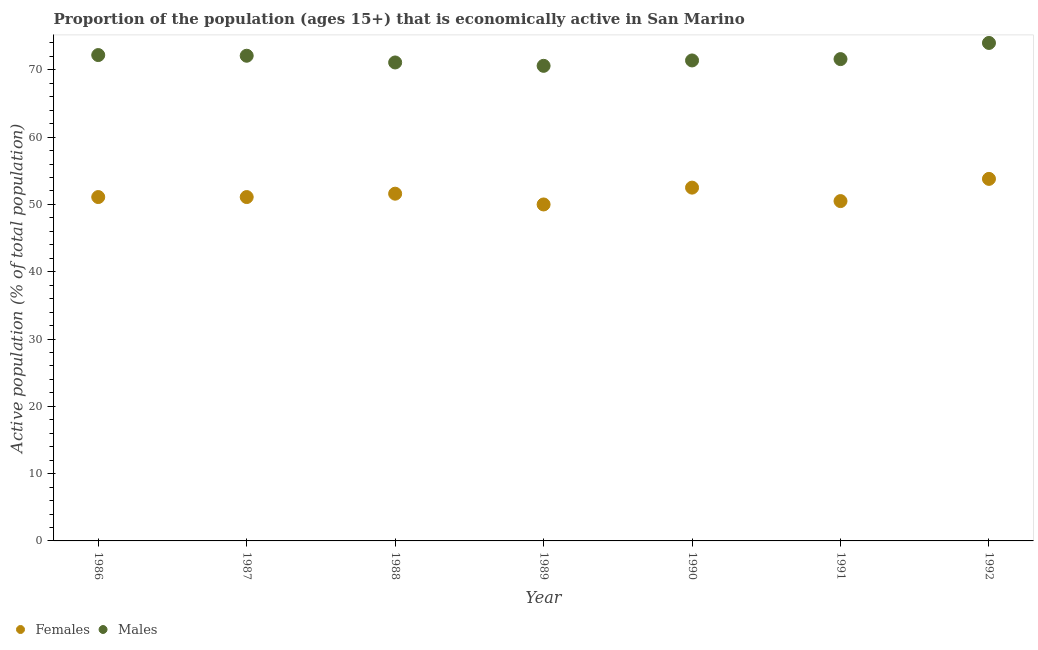How many different coloured dotlines are there?
Your answer should be very brief. 2. Is the number of dotlines equal to the number of legend labels?
Provide a succinct answer. Yes. What is the percentage of economically active female population in 1987?
Make the answer very short. 51.1. Across all years, what is the maximum percentage of economically active female population?
Ensure brevity in your answer.  53.8. In which year was the percentage of economically active female population minimum?
Make the answer very short. 1989. What is the total percentage of economically active female population in the graph?
Provide a short and direct response. 360.6. What is the difference between the percentage of economically active male population in 1987 and the percentage of economically active female population in 1991?
Keep it short and to the point. 21.6. What is the average percentage of economically active female population per year?
Ensure brevity in your answer.  51.51. In the year 1990, what is the difference between the percentage of economically active female population and percentage of economically active male population?
Keep it short and to the point. -18.9. In how many years, is the percentage of economically active female population greater than 42 %?
Provide a short and direct response. 7. What is the ratio of the percentage of economically active female population in 1987 to that in 1990?
Provide a short and direct response. 0.97. Is the percentage of economically active female population in 1989 less than that in 1991?
Your answer should be compact. Yes. Is the difference between the percentage of economically active female population in 1990 and 1992 greater than the difference between the percentage of economically active male population in 1990 and 1992?
Offer a terse response. Yes. What is the difference between the highest and the second highest percentage of economically active male population?
Make the answer very short. 1.8. What is the difference between the highest and the lowest percentage of economically active female population?
Your response must be concise. 3.8. In how many years, is the percentage of economically active female population greater than the average percentage of economically active female population taken over all years?
Provide a succinct answer. 3. Is the percentage of economically active female population strictly greater than the percentage of economically active male population over the years?
Make the answer very short. No. What is the difference between two consecutive major ticks on the Y-axis?
Your answer should be very brief. 10. Does the graph contain grids?
Keep it short and to the point. No. How are the legend labels stacked?
Your answer should be very brief. Horizontal. What is the title of the graph?
Provide a succinct answer. Proportion of the population (ages 15+) that is economically active in San Marino. Does "National Tourists" appear as one of the legend labels in the graph?
Offer a very short reply. No. What is the label or title of the X-axis?
Ensure brevity in your answer.  Year. What is the label or title of the Y-axis?
Your answer should be compact. Active population (% of total population). What is the Active population (% of total population) of Females in 1986?
Your answer should be very brief. 51.1. What is the Active population (% of total population) of Males in 1986?
Provide a succinct answer. 72.2. What is the Active population (% of total population) of Females in 1987?
Ensure brevity in your answer.  51.1. What is the Active population (% of total population) of Males in 1987?
Your answer should be compact. 72.1. What is the Active population (% of total population) of Females in 1988?
Provide a short and direct response. 51.6. What is the Active population (% of total population) of Males in 1988?
Ensure brevity in your answer.  71.1. What is the Active population (% of total population) of Females in 1989?
Provide a short and direct response. 50. What is the Active population (% of total population) of Males in 1989?
Provide a short and direct response. 70.6. What is the Active population (% of total population) of Females in 1990?
Keep it short and to the point. 52.5. What is the Active population (% of total population) of Males in 1990?
Offer a terse response. 71.4. What is the Active population (% of total population) of Females in 1991?
Provide a short and direct response. 50.5. What is the Active population (% of total population) in Males in 1991?
Provide a succinct answer. 71.6. What is the Active population (% of total population) of Females in 1992?
Offer a very short reply. 53.8. What is the Active population (% of total population) of Males in 1992?
Your answer should be compact. 74. Across all years, what is the maximum Active population (% of total population) in Females?
Provide a short and direct response. 53.8. Across all years, what is the maximum Active population (% of total population) in Males?
Ensure brevity in your answer.  74. Across all years, what is the minimum Active population (% of total population) of Females?
Provide a succinct answer. 50. Across all years, what is the minimum Active population (% of total population) in Males?
Offer a terse response. 70.6. What is the total Active population (% of total population) in Females in the graph?
Keep it short and to the point. 360.6. What is the total Active population (% of total population) of Males in the graph?
Make the answer very short. 503. What is the difference between the Active population (% of total population) in Males in 1986 and that in 1987?
Keep it short and to the point. 0.1. What is the difference between the Active population (% of total population) of Females in 1986 and that in 1988?
Make the answer very short. -0.5. What is the difference between the Active population (% of total population) in Males in 1986 and that in 1988?
Make the answer very short. 1.1. What is the difference between the Active population (% of total population) of Males in 1986 and that in 1990?
Provide a succinct answer. 0.8. What is the difference between the Active population (% of total population) in Females in 1986 and that in 1991?
Your answer should be very brief. 0.6. What is the difference between the Active population (% of total population) in Males in 1986 and that in 1991?
Your response must be concise. 0.6. What is the difference between the Active population (% of total population) in Males in 1986 and that in 1992?
Your response must be concise. -1.8. What is the difference between the Active population (% of total population) in Females in 1987 and that in 1988?
Provide a short and direct response. -0.5. What is the difference between the Active population (% of total population) of Males in 1987 and that in 1988?
Offer a terse response. 1. What is the difference between the Active population (% of total population) of Males in 1987 and that in 1989?
Give a very brief answer. 1.5. What is the difference between the Active population (% of total population) in Females in 1987 and that in 1990?
Ensure brevity in your answer.  -1.4. What is the difference between the Active population (% of total population) in Males in 1987 and that in 1990?
Your answer should be very brief. 0.7. What is the difference between the Active population (% of total population) of Females in 1988 and that in 1990?
Provide a succinct answer. -0.9. What is the difference between the Active population (% of total population) in Males in 1988 and that in 1991?
Make the answer very short. -0.5. What is the difference between the Active population (% of total population) in Males in 1988 and that in 1992?
Give a very brief answer. -2.9. What is the difference between the Active population (% of total population) in Males in 1989 and that in 1990?
Provide a succinct answer. -0.8. What is the difference between the Active population (% of total population) of Females in 1989 and that in 1991?
Give a very brief answer. -0.5. What is the difference between the Active population (% of total population) in Males in 1989 and that in 1991?
Make the answer very short. -1. What is the difference between the Active population (% of total population) of Females in 1989 and that in 1992?
Provide a short and direct response. -3.8. What is the difference between the Active population (% of total population) in Females in 1990 and that in 1991?
Your response must be concise. 2. What is the difference between the Active population (% of total population) in Males in 1990 and that in 1991?
Your response must be concise. -0.2. What is the difference between the Active population (% of total population) of Females in 1990 and that in 1992?
Your answer should be very brief. -1.3. What is the difference between the Active population (% of total population) of Males in 1991 and that in 1992?
Your answer should be compact. -2.4. What is the difference between the Active population (% of total population) in Females in 1986 and the Active population (% of total population) in Males in 1989?
Provide a short and direct response. -19.5. What is the difference between the Active population (% of total population) in Females in 1986 and the Active population (% of total population) in Males in 1990?
Your response must be concise. -20.3. What is the difference between the Active population (% of total population) in Females in 1986 and the Active population (% of total population) in Males in 1991?
Make the answer very short. -20.5. What is the difference between the Active population (% of total population) of Females in 1986 and the Active population (% of total population) of Males in 1992?
Your answer should be compact. -22.9. What is the difference between the Active population (% of total population) in Females in 1987 and the Active population (% of total population) in Males in 1988?
Offer a very short reply. -20. What is the difference between the Active population (% of total population) in Females in 1987 and the Active population (% of total population) in Males in 1989?
Make the answer very short. -19.5. What is the difference between the Active population (% of total population) of Females in 1987 and the Active population (% of total population) of Males in 1990?
Your response must be concise. -20.3. What is the difference between the Active population (% of total population) in Females in 1987 and the Active population (% of total population) in Males in 1991?
Provide a short and direct response. -20.5. What is the difference between the Active population (% of total population) of Females in 1987 and the Active population (% of total population) of Males in 1992?
Your answer should be very brief. -22.9. What is the difference between the Active population (% of total population) in Females in 1988 and the Active population (% of total population) in Males in 1989?
Ensure brevity in your answer.  -19. What is the difference between the Active population (% of total population) of Females in 1988 and the Active population (% of total population) of Males in 1990?
Provide a succinct answer. -19.8. What is the difference between the Active population (% of total population) in Females in 1988 and the Active population (% of total population) in Males in 1991?
Ensure brevity in your answer.  -20. What is the difference between the Active population (% of total population) in Females in 1988 and the Active population (% of total population) in Males in 1992?
Your answer should be compact. -22.4. What is the difference between the Active population (% of total population) of Females in 1989 and the Active population (% of total population) of Males in 1990?
Provide a succinct answer. -21.4. What is the difference between the Active population (% of total population) in Females in 1989 and the Active population (% of total population) in Males in 1991?
Ensure brevity in your answer.  -21.6. What is the difference between the Active population (% of total population) of Females in 1990 and the Active population (% of total population) of Males in 1991?
Your answer should be very brief. -19.1. What is the difference between the Active population (% of total population) of Females in 1990 and the Active population (% of total population) of Males in 1992?
Provide a short and direct response. -21.5. What is the difference between the Active population (% of total population) of Females in 1991 and the Active population (% of total population) of Males in 1992?
Make the answer very short. -23.5. What is the average Active population (% of total population) of Females per year?
Offer a terse response. 51.51. What is the average Active population (% of total population) of Males per year?
Provide a succinct answer. 71.86. In the year 1986, what is the difference between the Active population (% of total population) in Females and Active population (% of total population) in Males?
Provide a succinct answer. -21.1. In the year 1987, what is the difference between the Active population (% of total population) in Females and Active population (% of total population) in Males?
Provide a short and direct response. -21. In the year 1988, what is the difference between the Active population (% of total population) in Females and Active population (% of total population) in Males?
Offer a terse response. -19.5. In the year 1989, what is the difference between the Active population (% of total population) in Females and Active population (% of total population) in Males?
Your response must be concise. -20.6. In the year 1990, what is the difference between the Active population (% of total population) of Females and Active population (% of total population) of Males?
Make the answer very short. -18.9. In the year 1991, what is the difference between the Active population (% of total population) of Females and Active population (% of total population) of Males?
Keep it short and to the point. -21.1. In the year 1992, what is the difference between the Active population (% of total population) in Females and Active population (% of total population) in Males?
Provide a succinct answer. -20.2. What is the ratio of the Active population (% of total population) of Females in 1986 to that in 1988?
Your answer should be very brief. 0.99. What is the ratio of the Active population (% of total population) in Males in 1986 to that in 1988?
Your answer should be compact. 1.02. What is the ratio of the Active population (% of total population) of Females in 1986 to that in 1989?
Provide a succinct answer. 1.02. What is the ratio of the Active population (% of total population) of Males in 1986 to that in 1989?
Your answer should be compact. 1.02. What is the ratio of the Active population (% of total population) in Females in 1986 to that in 1990?
Provide a short and direct response. 0.97. What is the ratio of the Active population (% of total population) of Males in 1986 to that in 1990?
Provide a short and direct response. 1.01. What is the ratio of the Active population (% of total population) of Females in 1986 to that in 1991?
Your response must be concise. 1.01. What is the ratio of the Active population (% of total population) of Males in 1986 to that in 1991?
Offer a very short reply. 1.01. What is the ratio of the Active population (% of total population) in Females in 1986 to that in 1992?
Offer a very short reply. 0.95. What is the ratio of the Active population (% of total population) in Males in 1986 to that in 1992?
Provide a succinct answer. 0.98. What is the ratio of the Active population (% of total population) of Females in 1987 to that in 1988?
Offer a very short reply. 0.99. What is the ratio of the Active population (% of total population) of Males in 1987 to that in 1988?
Offer a terse response. 1.01. What is the ratio of the Active population (% of total population) of Males in 1987 to that in 1989?
Keep it short and to the point. 1.02. What is the ratio of the Active population (% of total population) in Females in 1987 to that in 1990?
Offer a very short reply. 0.97. What is the ratio of the Active population (% of total population) of Males in 1987 to that in 1990?
Offer a very short reply. 1.01. What is the ratio of the Active population (% of total population) of Females in 1987 to that in 1991?
Offer a very short reply. 1.01. What is the ratio of the Active population (% of total population) in Males in 1987 to that in 1991?
Your answer should be very brief. 1.01. What is the ratio of the Active population (% of total population) of Females in 1987 to that in 1992?
Give a very brief answer. 0.95. What is the ratio of the Active population (% of total population) in Males in 1987 to that in 1992?
Keep it short and to the point. 0.97. What is the ratio of the Active population (% of total population) in Females in 1988 to that in 1989?
Give a very brief answer. 1.03. What is the ratio of the Active population (% of total population) in Males in 1988 to that in 1989?
Offer a terse response. 1.01. What is the ratio of the Active population (% of total population) in Females in 1988 to that in 1990?
Your response must be concise. 0.98. What is the ratio of the Active population (% of total population) in Males in 1988 to that in 1990?
Make the answer very short. 1. What is the ratio of the Active population (% of total population) of Females in 1988 to that in 1991?
Provide a succinct answer. 1.02. What is the ratio of the Active population (% of total population) of Females in 1988 to that in 1992?
Your response must be concise. 0.96. What is the ratio of the Active population (% of total population) of Males in 1988 to that in 1992?
Give a very brief answer. 0.96. What is the ratio of the Active population (% of total population) in Males in 1989 to that in 1990?
Make the answer very short. 0.99. What is the ratio of the Active population (% of total population) in Females in 1989 to that in 1991?
Offer a terse response. 0.99. What is the ratio of the Active population (% of total population) in Females in 1989 to that in 1992?
Offer a terse response. 0.93. What is the ratio of the Active population (% of total population) in Males in 1989 to that in 1992?
Offer a very short reply. 0.95. What is the ratio of the Active population (% of total population) in Females in 1990 to that in 1991?
Your response must be concise. 1.04. What is the ratio of the Active population (% of total population) in Males in 1990 to that in 1991?
Make the answer very short. 1. What is the ratio of the Active population (% of total population) in Females in 1990 to that in 1992?
Your answer should be very brief. 0.98. What is the ratio of the Active population (% of total population) of Males in 1990 to that in 1992?
Offer a terse response. 0.96. What is the ratio of the Active population (% of total population) of Females in 1991 to that in 1992?
Ensure brevity in your answer.  0.94. What is the ratio of the Active population (% of total population) of Males in 1991 to that in 1992?
Your answer should be compact. 0.97. What is the difference between the highest and the second highest Active population (% of total population) of Females?
Make the answer very short. 1.3. What is the difference between the highest and the lowest Active population (% of total population) in Males?
Give a very brief answer. 3.4. 